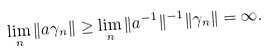Convert formula to latex. <formula><loc_0><loc_0><loc_500><loc_500>\lim _ { n } \| a \gamma _ { n } \| \geq \lim _ { n } \| a ^ { - 1 } \| ^ { - 1 } \| \gamma _ { n } \| = \infty .</formula> 